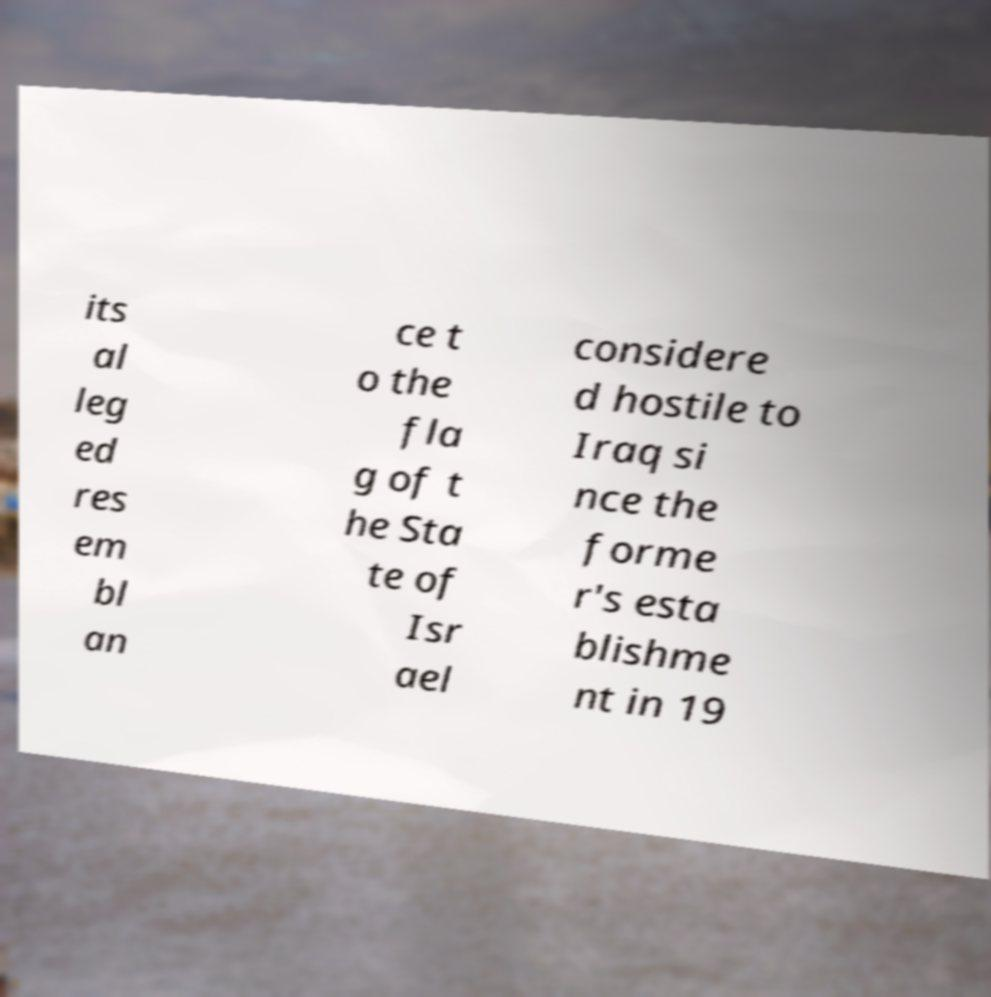Please identify and transcribe the text found in this image. its al leg ed res em bl an ce t o the fla g of t he Sta te of Isr ael considere d hostile to Iraq si nce the forme r's esta blishme nt in 19 